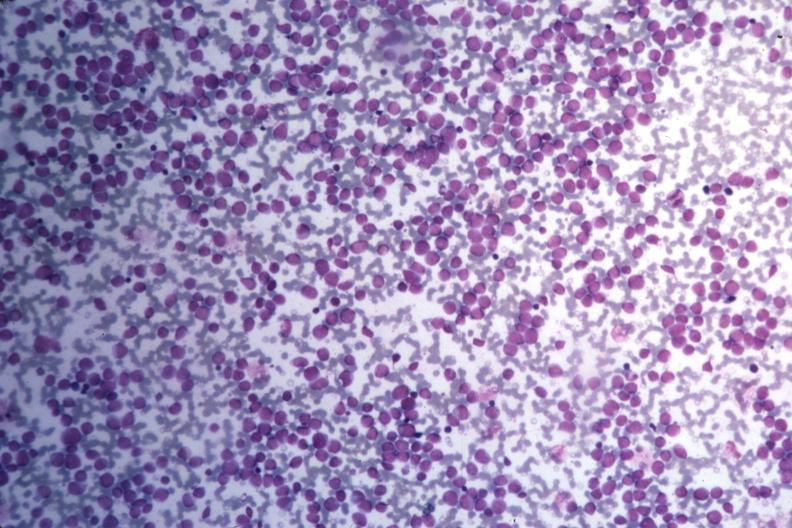do infarcts stain many pleomorphic blast cells readily seen?
Answer the question using a single word or phrase. No 